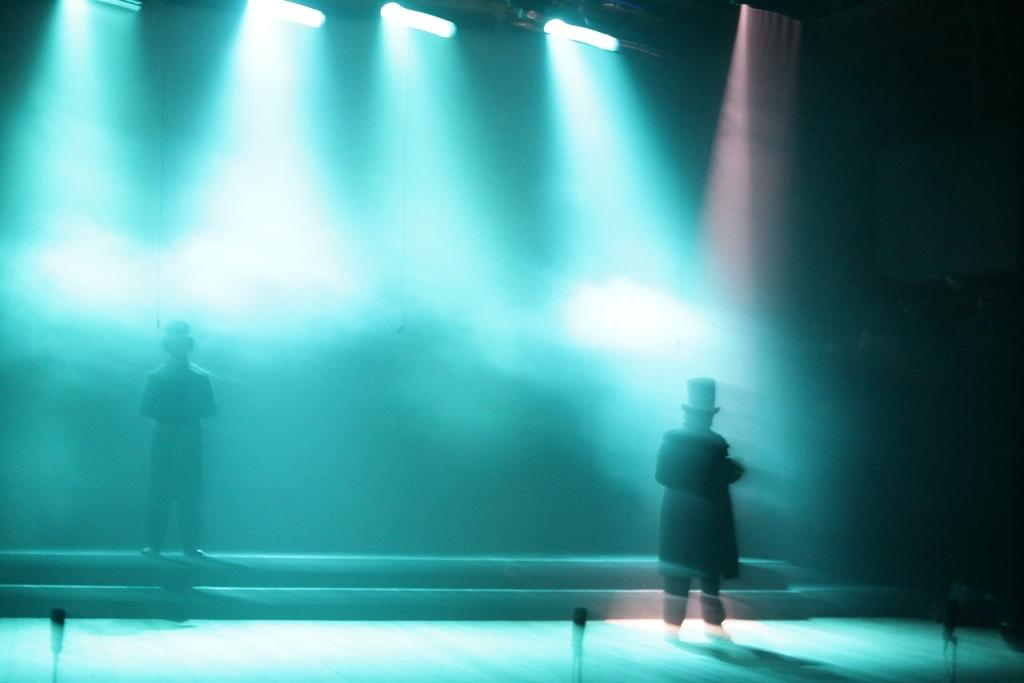How many people are in the image? There are 2 people standing in the image. What objects can be seen at the front of the image? There are microphones at the front of the image. What architectural feature is present in the image? There are stairs in the image. What type of illumination is present at the top of the image? Lights are present at the top of the image. What type of quill is being used by the person on the left in the image? There is no quill present in the image; it is not a historical or literary scene. 